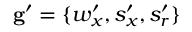<formula> <loc_0><loc_0><loc_500><loc_500>g ^ { \prime } = \{ w _ { x } ^ { \prime } , s _ { x } ^ { \prime } , s _ { r } ^ { \prime } \}</formula> 